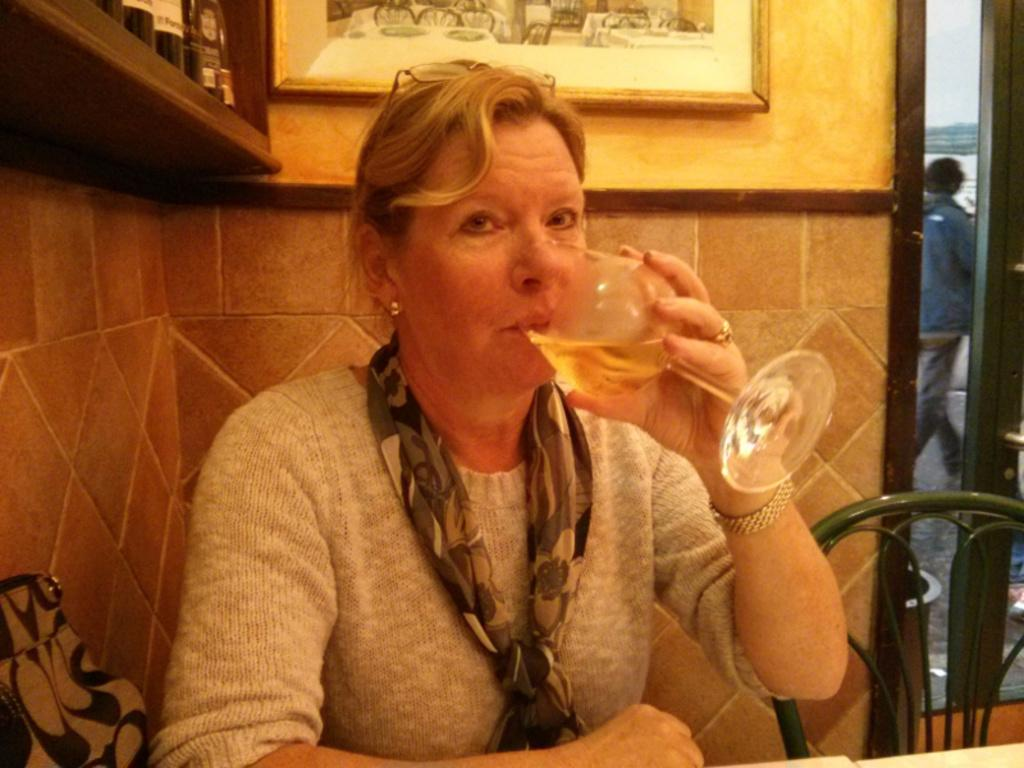What is the primary subject in the image? There is a woman in the image. What is the woman doing in the image? The woman is sitting and drinking. Can you describe the chair the woman is sitting on? There is a green chair in the image. What is happening in the background of the image? There is a person walking in the background of the image. What type of soap is the woman using in the image? There is no soap present in the image. The woman is drinking, not using soap. 